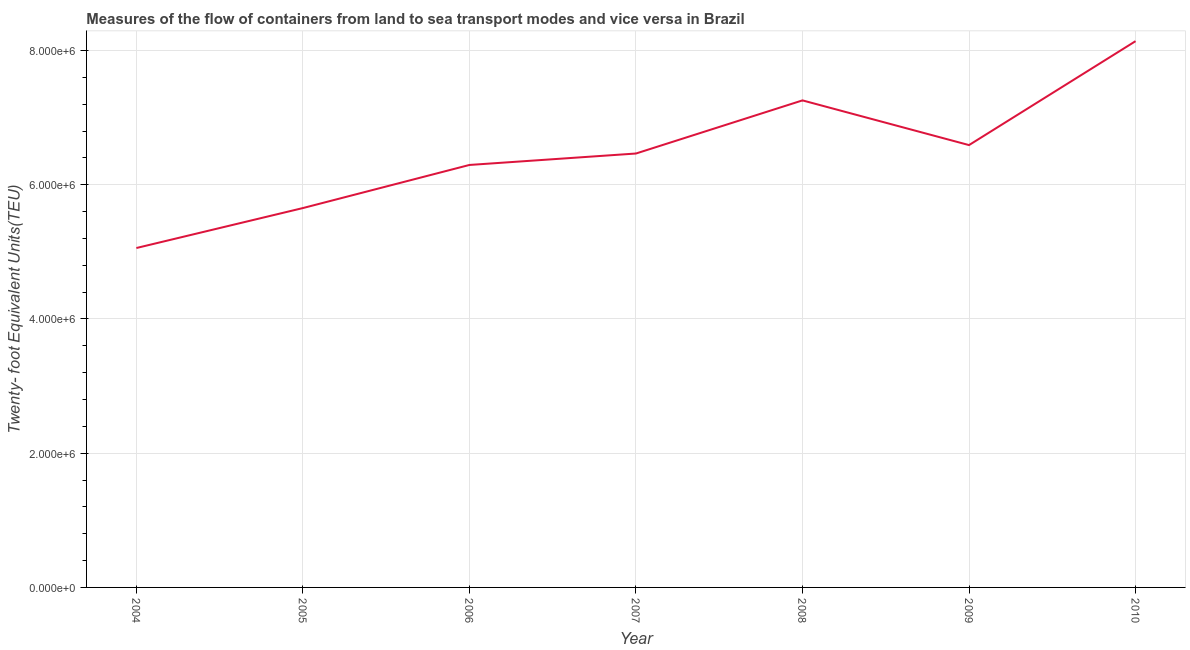What is the container port traffic in 2008?
Provide a succinct answer. 7.26e+06. Across all years, what is the maximum container port traffic?
Provide a succinct answer. 8.14e+06. Across all years, what is the minimum container port traffic?
Offer a terse response. 5.06e+06. In which year was the container port traffic minimum?
Your answer should be very brief. 2004. What is the sum of the container port traffic?
Your answer should be very brief. 4.55e+07. What is the difference between the container port traffic in 2006 and 2009?
Offer a terse response. -2.96e+05. What is the average container port traffic per year?
Keep it short and to the point. 6.49e+06. What is the median container port traffic?
Your answer should be very brief. 6.46e+06. Do a majority of the years between 2007 and 2008 (inclusive) have container port traffic greater than 5600000 TEU?
Provide a succinct answer. Yes. What is the ratio of the container port traffic in 2005 to that in 2006?
Make the answer very short. 0.9. Is the container port traffic in 2006 less than that in 2008?
Provide a short and direct response. Yes. Is the difference between the container port traffic in 2005 and 2006 greater than the difference between any two years?
Offer a very short reply. No. What is the difference between the highest and the second highest container port traffic?
Offer a very short reply. 8.82e+05. What is the difference between the highest and the lowest container port traffic?
Offer a terse response. 3.08e+06. In how many years, is the container port traffic greater than the average container port traffic taken over all years?
Offer a very short reply. 3. Does the container port traffic monotonically increase over the years?
Ensure brevity in your answer.  No. How many years are there in the graph?
Give a very brief answer. 7. Does the graph contain any zero values?
Give a very brief answer. No. What is the title of the graph?
Your answer should be compact. Measures of the flow of containers from land to sea transport modes and vice versa in Brazil. What is the label or title of the X-axis?
Ensure brevity in your answer.  Year. What is the label or title of the Y-axis?
Provide a short and direct response. Twenty- foot Equivalent Units(TEU). What is the Twenty- foot Equivalent Units(TEU) in 2004?
Make the answer very short. 5.06e+06. What is the Twenty- foot Equivalent Units(TEU) in 2005?
Provide a short and direct response. 5.65e+06. What is the Twenty- foot Equivalent Units(TEU) of 2006?
Your answer should be very brief. 6.29e+06. What is the Twenty- foot Equivalent Units(TEU) of 2007?
Offer a terse response. 6.46e+06. What is the Twenty- foot Equivalent Units(TEU) of 2008?
Make the answer very short. 7.26e+06. What is the Twenty- foot Equivalent Units(TEU) in 2009?
Offer a terse response. 6.59e+06. What is the Twenty- foot Equivalent Units(TEU) in 2010?
Offer a terse response. 8.14e+06. What is the difference between the Twenty- foot Equivalent Units(TEU) in 2004 and 2005?
Give a very brief answer. -5.95e+05. What is the difference between the Twenty- foot Equivalent Units(TEU) in 2004 and 2006?
Offer a very short reply. -1.24e+06. What is the difference between the Twenty- foot Equivalent Units(TEU) in 2004 and 2007?
Offer a very short reply. -1.41e+06. What is the difference between the Twenty- foot Equivalent Units(TEU) in 2004 and 2008?
Make the answer very short. -2.20e+06. What is the difference between the Twenty- foot Equivalent Units(TEU) in 2004 and 2009?
Make the answer very short. -1.53e+06. What is the difference between the Twenty- foot Equivalent Units(TEU) in 2004 and 2010?
Your response must be concise. -3.08e+06. What is the difference between the Twenty- foot Equivalent Units(TEU) in 2005 and 2006?
Offer a terse response. -6.42e+05. What is the difference between the Twenty- foot Equivalent Units(TEU) in 2005 and 2007?
Provide a succinct answer. -8.13e+05. What is the difference between the Twenty- foot Equivalent Units(TEU) in 2005 and 2008?
Your answer should be compact. -1.60e+06. What is the difference between the Twenty- foot Equivalent Units(TEU) in 2005 and 2009?
Keep it short and to the point. -9.38e+05. What is the difference between the Twenty- foot Equivalent Units(TEU) in 2005 and 2010?
Give a very brief answer. -2.49e+06. What is the difference between the Twenty- foot Equivalent Units(TEU) in 2006 and 2007?
Make the answer very short. -1.70e+05. What is the difference between the Twenty- foot Equivalent Units(TEU) in 2006 and 2008?
Offer a very short reply. -9.62e+05. What is the difference between the Twenty- foot Equivalent Units(TEU) in 2006 and 2009?
Your answer should be very brief. -2.96e+05. What is the difference between the Twenty- foot Equivalent Units(TEU) in 2006 and 2010?
Make the answer very short. -1.84e+06. What is the difference between the Twenty- foot Equivalent Units(TEU) in 2007 and 2008?
Offer a very short reply. -7.92e+05. What is the difference between the Twenty- foot Equivalent Units(TEU) in 2007 and 2009?
Provide a short and direct response. -1.26e+05. What is the difference between the Twenty- foot Equivalent Units(TEU) in 2007 and 2010?
Provide a succinct answer. -1.67e+06. What is the difference between the Twenty- foot Equivalent Units(TEU) in 2008 and 2009?
Your response must be concise. 6.66e+05. What is the difference between the Twenty- foot Equivalent Units(TEU) in 2008 and 2010?
Your answer should be compact. -8.82e+05. What is the difference between the Twenty- foot Equivalent Units(TEU) in 2009 and 2010?
Ensure brevity in your answer.  -1.55e+06. What is the ratio of the Twenty- foot Equivalent Units(TEU) in 2004 to that in 2005?
Keep it short and to the point. 0.9. What is the ratio of the Twenty- foot Equivalent Units(TEU) in 2004 to that in 2006?
Your answer should be compact. 0.8. What is the ratio of the Twenty- foot Equivalent Units(TEU) in 2004 to that in 2007?
Offer a very short reply. 0.78. What is the ratio of the Twenty- foot Equivalent Units(TEU) in 2004 to that in 2008?
Your answer should be very brief. 0.7. What is the ratio of the Twenty- foot Equivalent Units(TEU) in 2004 to that in 2009?
Keep it short and to the point. 0.77. What is the ratio of the Twenty- foot Equivalent Units(TEU) in 2004 to that in 2010?
Provide a short and direct response. 0.62. What is the ratio of the Twenty- foot Equivalent Units(TEU) in 2005 to that in 2006?
Offer a very short reply. 0.9. What is the ratio of the Twenty- foot Equivalent Units(TEU) in 2005 to that in 2007?
Your answer should be very brief. 0.87. What is the ratio of the Twenty- foot Equivalent Units(TEU) in 2005 to that in 2008?
Give a very brief answer. 0.78. What is the ratio of the Twenty- foot Equivalent Units(TEU) in 2005 to that in 2009?
Give a very brief answer. 0.86. What is the ratio of the Twenty- foot Equivalent Units(TEU) in 2005 to that in 2010?
Your answer should be very brief. 0.69. What is the ratio of the Twenty- foot Equivalent Units(TEU) in 2006 to that in 2008?
Ensure brevity in your answer.  0.87. What is the ratio of the Twenty- foot Equivalent Units(TEU) in 2006 to that in 2009?
Offer a very short reply. 0.95. What is the ratio of the Twenty- foot Equivalent Units(TEU) in 2006 to that in 2010?
Offer a very short reply. 0.77. What is the ratio of the Twenty- foot Equivalent Units(TEU) in 2007 to that in 2008?
Offer a terse response. 0.89. What is the ratio of the Twenty- foot Equivalent Units(TEU) in 2007 to that in 2009?
Your answer should be compact. 0.98. What is the ratio of the Twenty- foot Equivalent Units(TEU) in 2007 to that in 2010?
Your response must be concise. 0.79. What is the ratio of the Twenty- foot Equivalent Units(TEU) in 2008 to that in 2009?
Your response must be concise. 1.1. What is the ratio of the Twenty- foot Equivalent Units(TEU) in 2008 to that in 2010?
Provide a short and direct response. 0.89. What is the ratio of the Twenty- foot Equivalent Units(TEU) in 2009 to that in 2010?
Your response must be concise. 0.81. 